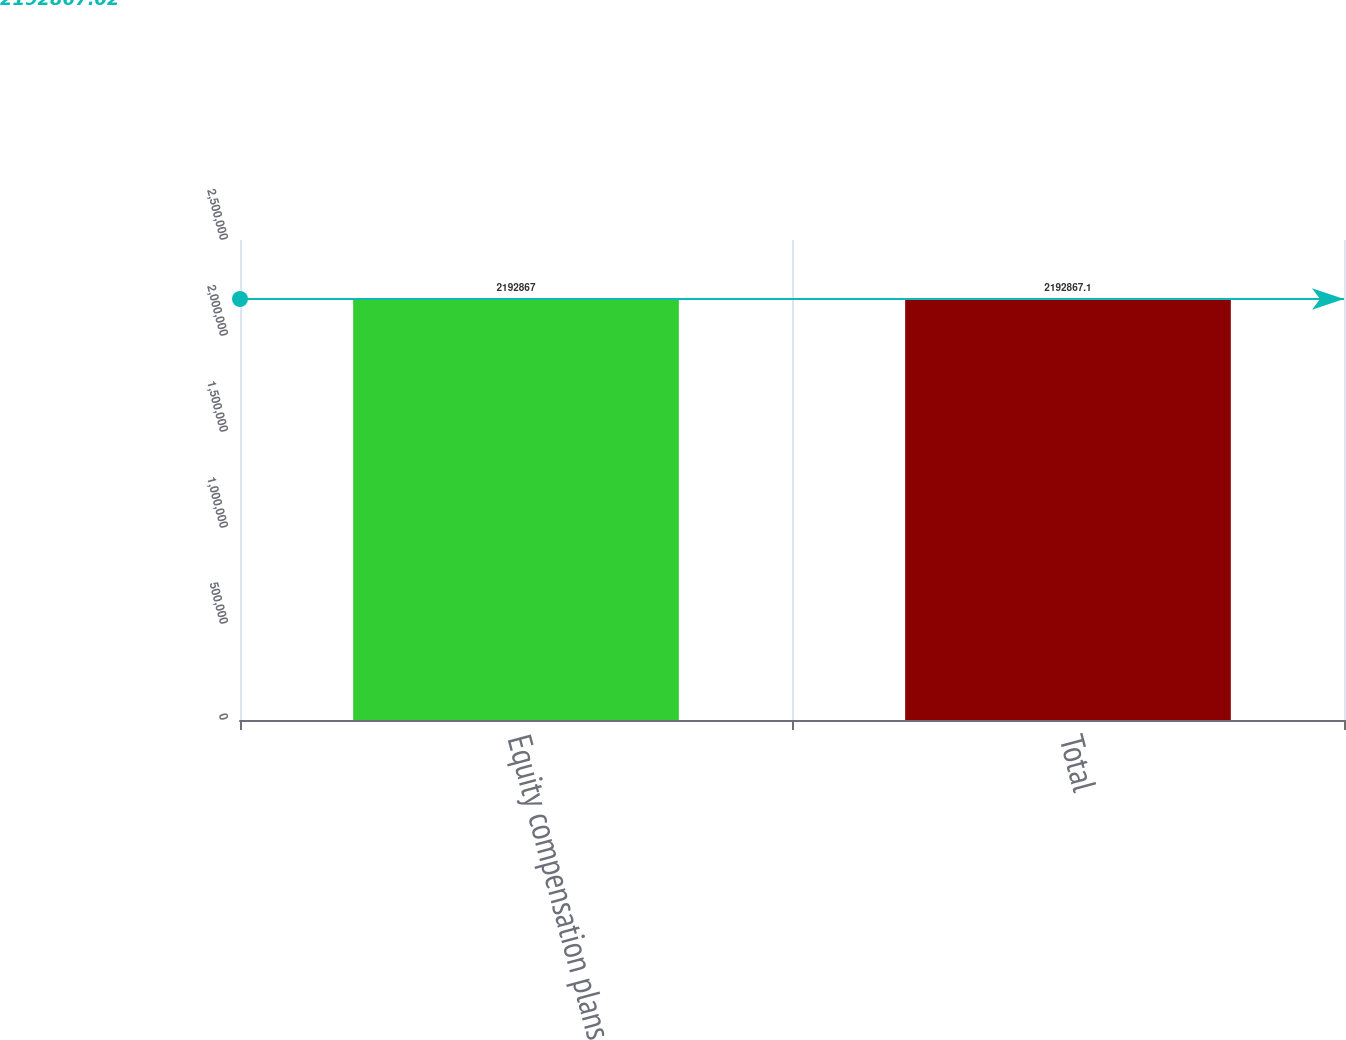Convert chart to OTSL. <chart><loc_0><loc_0><loc_500><loc_500><bar_chart><fcel>Equity compensation plans<fcel>Total<nl><fcel>2.19287e+06<fcel>2.19287e+06<nl></chart> 